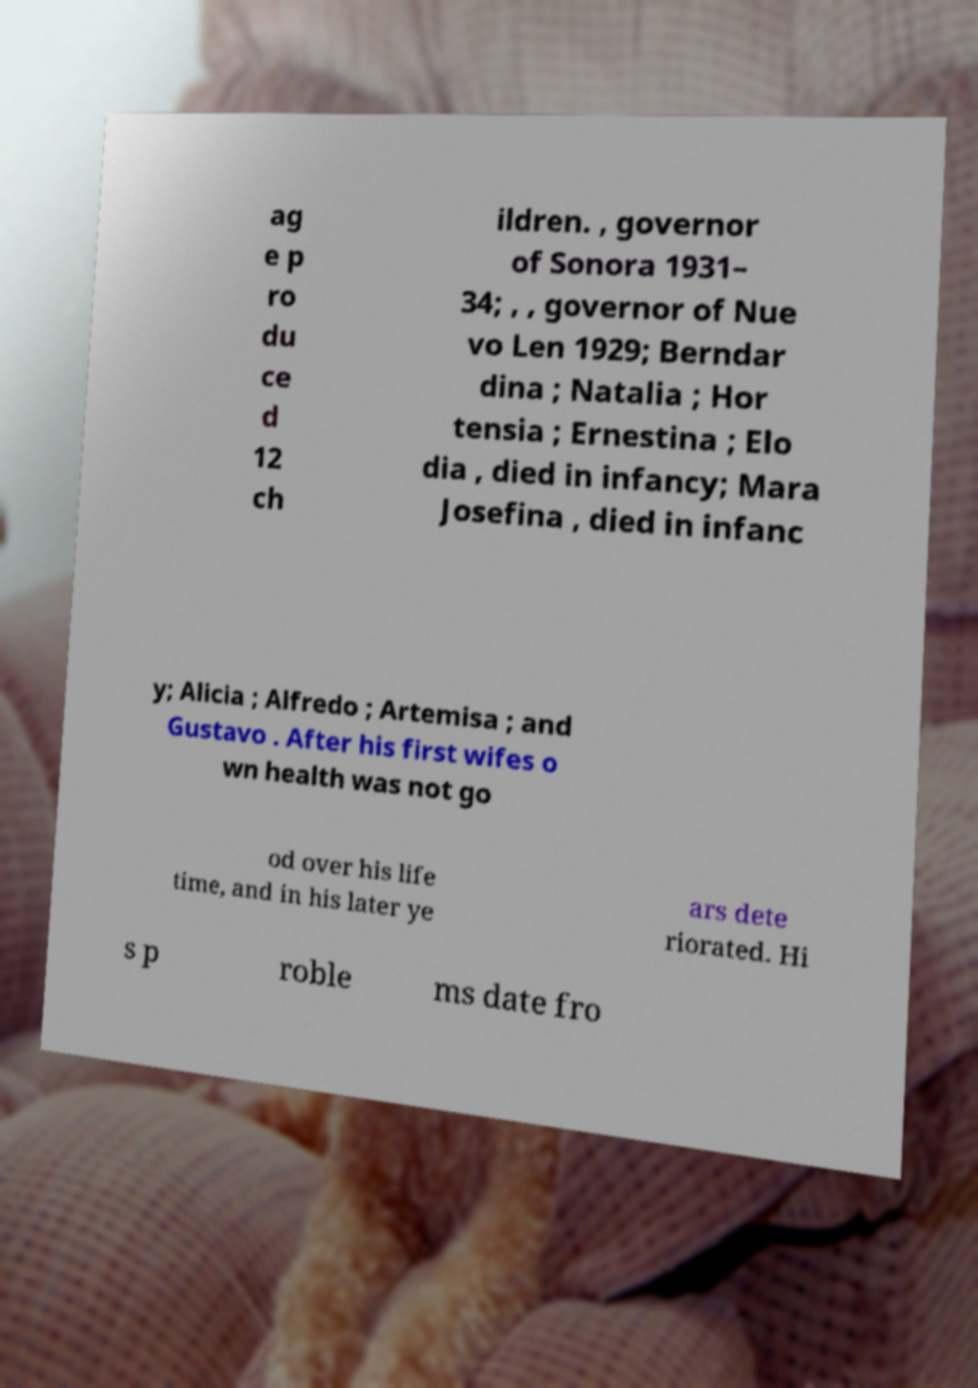I need the written content from this picture converted into text. Can you do that? ag e p ro du ce d 12 ch ildren. , governor of Sonora 1931– 34; , , governor of Nue vo Len 1929; Berndar dina ; Natalia ; Hor tensia ; Ernestina ; Elo dia , died in infancy; Mara Josefina , died in infanc y; Alicia ; Alfredo ; Artemisa ; and Gustavo . After his first wifes o wn health was not go od over his life time, and in his later ye ars dete riorated. Hi s p roble ms date fro 